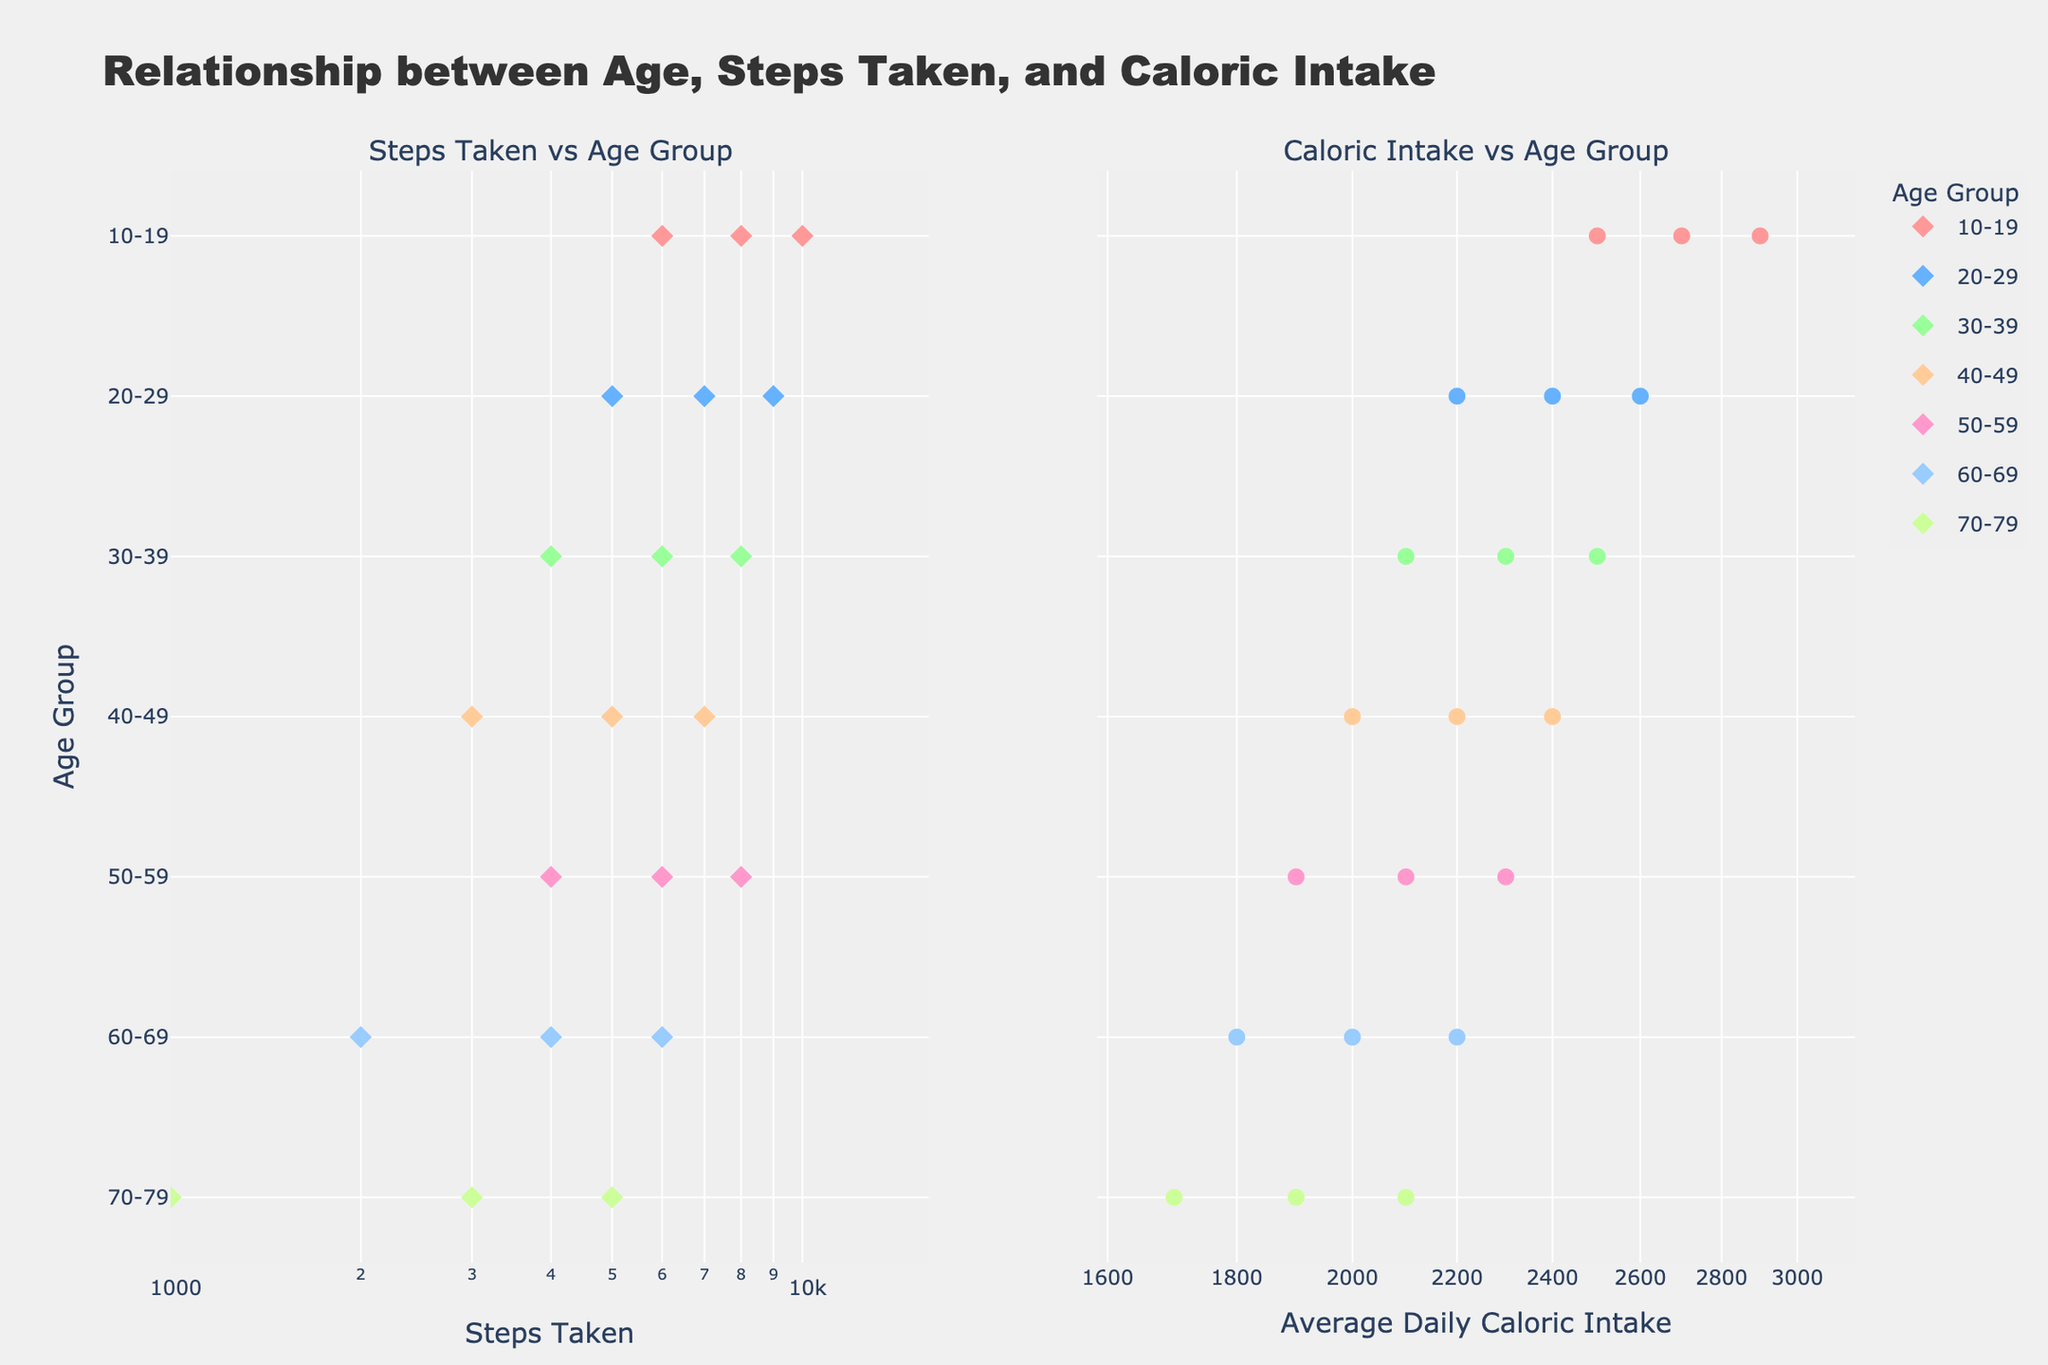What is the title of the entire figure? The title is located at the top of the plot. It reads "Relationship between Age, Steps Taken, and Caloric Intake".
Answer: Relationship between Age, Steps Taken, and Caloric Intake Which age group takes the least number of steps on average? Based on the left subplot showing "Steps Taken vs Age Group", the age group 70-79 has the lowest number of steps, with entries as low as 1000 steps.
Answer: 70-79 What is the average daily caloric intake for the 30-39 age group? From the right subplot, the data points corresponding to the 30-39 age group have caloric intake values of 2100, 2300, and 2500. The average is calculated as (2100 + 2300 + 2500) / 3 = 6900 / 3 = 2300.
Answer: 2300 Which age group has both the highest caloric intake and the highest number of steps? By looking at both subplots, the age group 10-19 has the highest caloric intake (up to 2900) and the highest number of steps (up to 10000).
Answer: 10-19 Between the age groups 40-49 and 50-59, which group has a higher maximum number of steps? Referring to the "Steps Taken vs Age Group" subplot, the 40-49 age group has a maximum of 7000 steps, while the 50-59 age group has a maximum of 8000 steps. Therefore, the 50-59 group has a higher maximum number of steps.
Answer: 50-59 For the age group 60-69, what is the range of average daily caloric intake? Observing the right subplot for the 60-69 age group, the average daily caloric intake ranges from 1800 to 2200.
Answer: 1800 to 2200 Which age group shows the greatest variability in steps taken? By examining the "Steps Taken vs Age Group" subplot, the 10-19 age group shows the greatest variability as the steps taken range from 6000 to 10000.
Answer: 10-19 What type of scale is used for the x-axis in both subplots? The x-axis in both subplots utilizes a logarithmic scale, as indicated by the log labels and the nature of the tick marks.
Answer: Logarithmic Does the 70-79 age group have any data points with an average daily caloric intake above 2100? Referencing the right subplot, the data points for the 70-79 age group all show caloric intake values below 2100, with the maximum being 2100.
Answer: No What is the correlation between steps taken and average daily caloric intake for the age group 20-29? From both subplots, for the 20-29 age group, higher steps taken correlate with higher average daily caloric intake. Points with 5000, 7000, and 9000 steps correspond to caloric intake values of 2200, 2400, and 2600 respectively, indicating a positive correlation.
Answer: Positive correlation 